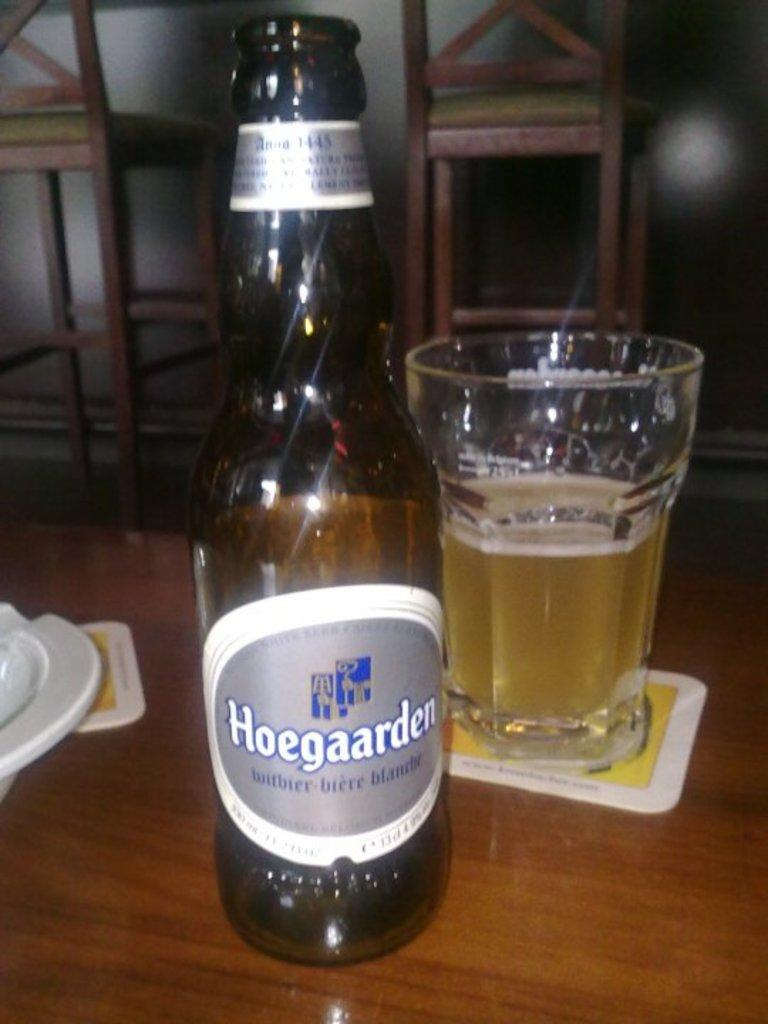<image>
Share a concise interpretation of the image provided. Half empty bottle of Hoegaarden next to a cup of beer. 